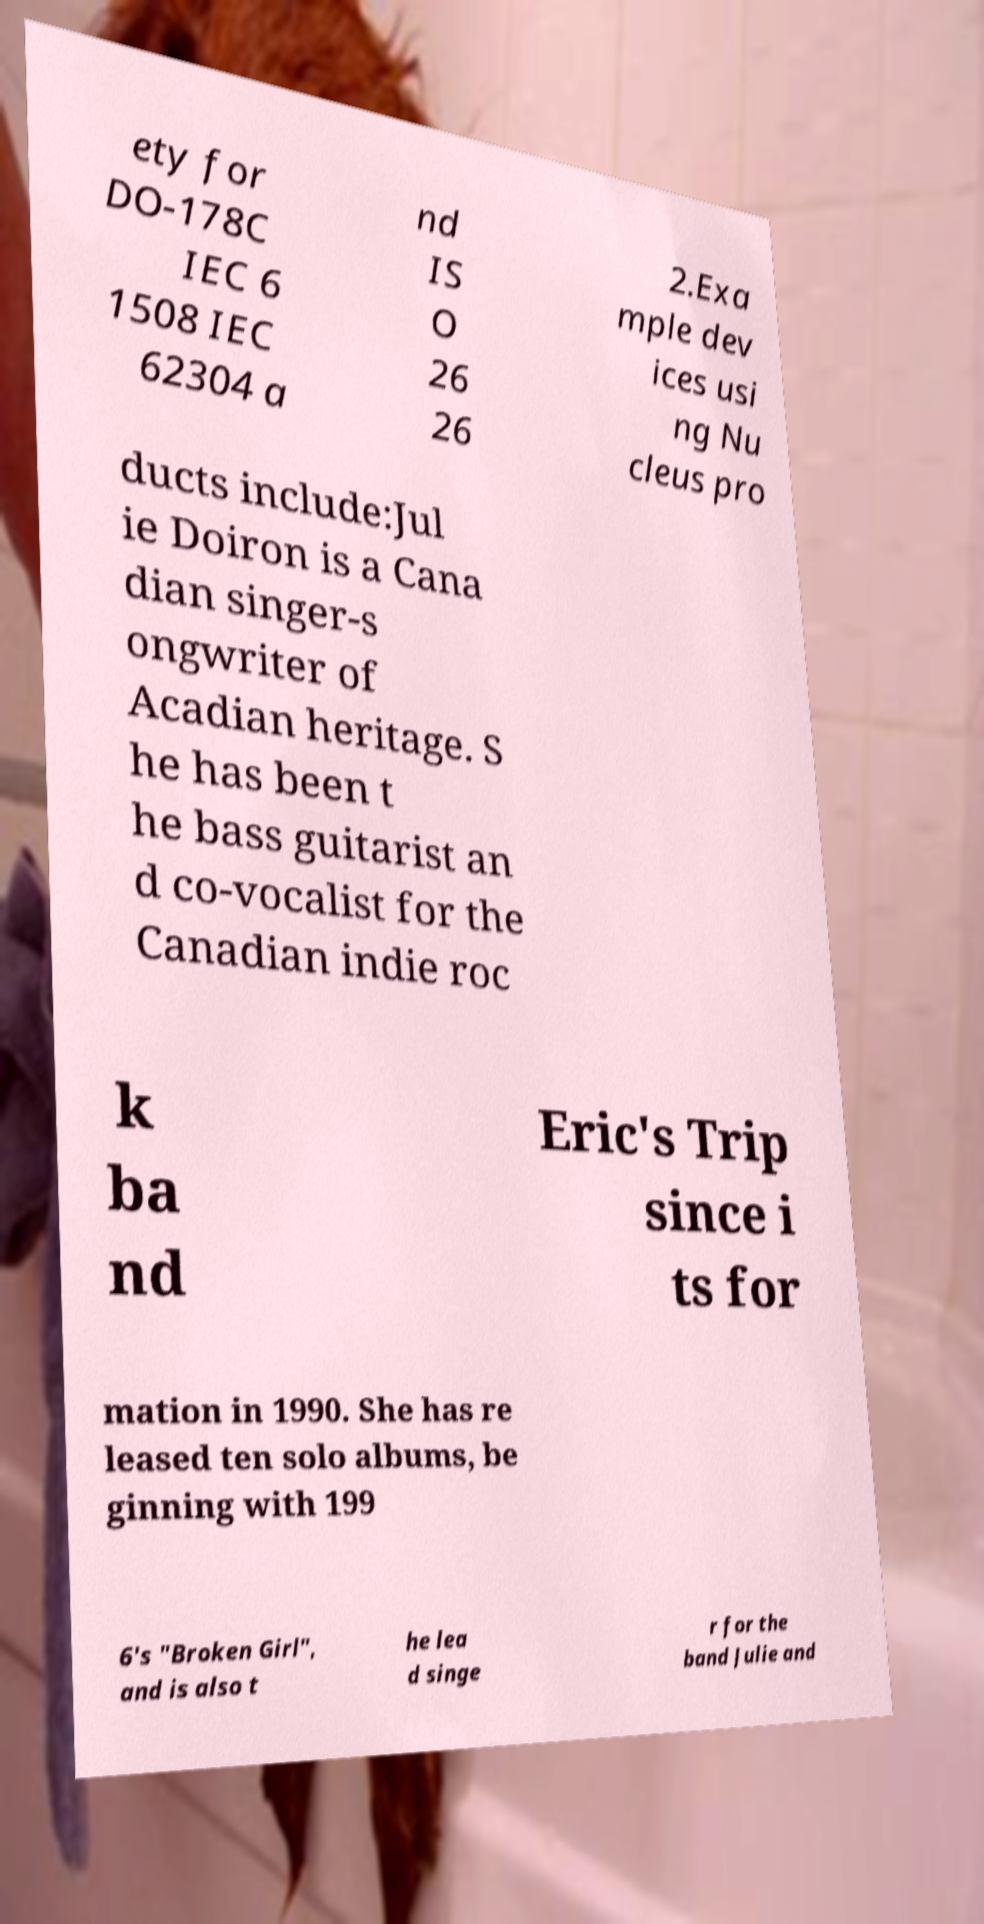Could you extract and type out the text from this image? ety for DO-178C IEC 6 1508 IEC 62304 a nd IS O 26 26 2.Exa mple dev ices usi ng Nu cleus pro ducts include:Jul ie Doiron is a Cana dian singer-s ongwriter of Acadian heritage. S he has been t he bass guitarist an d co-vocalist for the Canadian indie roc k ba nd Eric's Trip since i ts for mation in 1990. She has re leased ten solo albums, be ginning with 199 6's "Broken Girl", and is also t he lea d singe r for the band Julie and 